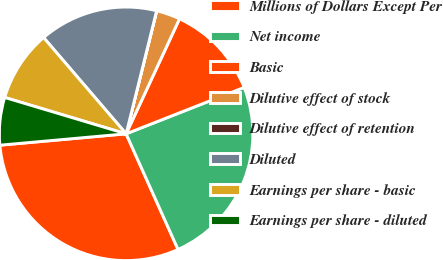Convert chart to OTSL. <chart><loc_0><loc_0><loc_500><loc_500><pie_chart><fcel>Millions of Dollars Except Per<fcel>Net income<fcel>Basic<fcel>Dilutive effect of stock<fcel>Dilutive effect of retention<fcel>Diluted<fcel>Earnings per share - basic<fcel>Earnings per share - diluted<nl><fcel>30.29%<fcel>24.25%<fcel>12.12%<fcel>3.04%<fcel>0.01%<fcel>15.15%<fcel>9.09%<fcel>6.06%<nl></chart> 